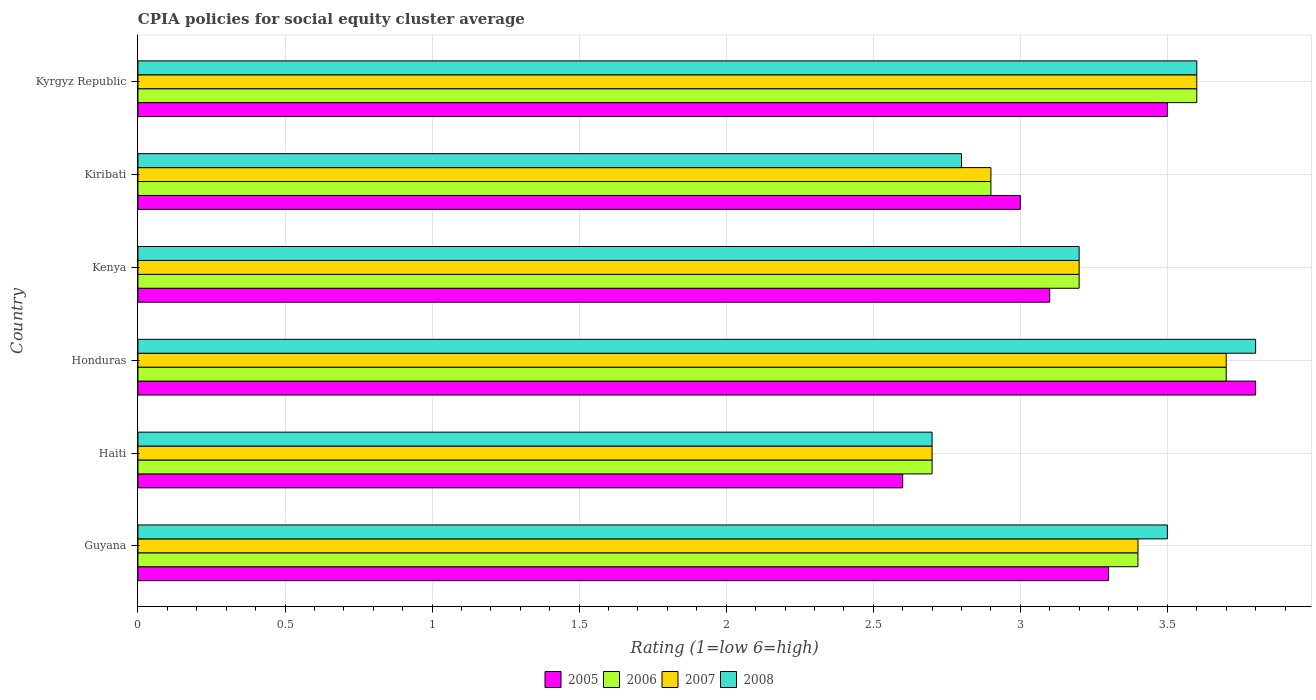What is the label of the 1st group of bars from the top?
Offer a very short reply. Kyrgyz Republic. In which country was the CPIA rating in 2008 maximum?
Your response must be concise. Honduras. In which country was the CPIA rating in 2007 minimum?
Give a very brief answer. Haiti. What is the total CPIA rating in 2005 in the graph?
Your response must be concise. 19.3. What is the difference between the CPIA rating in 2005 in Haiti and that in Kiribati?
Provide a succinct answer. -0.4. What is the difference between the CPIA rating in 2005 in Kyrgyz Republic and the CPIA rating in 2007 in Kenya?
Keep it short and to the point. 0.3. What is the average CPIA rating in 2008 per country?
Provide a short and direct response. 3.27. What is the difference between the CPIA rating in 2006 and CPIA rating in 2007 in Guyana?
Ensure brevity in your answer.  0. In how many countries, is the CPIA rating in 2005 greater than 3.7 ?
Your answer should be very brief. 1. What is the ratio of the CPIA rating in 2005 in Kiribati to that in Kyrgyz Republic?
Offer a terse response. 0.86. Is the CPIA rating in 2005 in Haiti less than that in Kyrgyz Republic?
Offer a very short reply. Yes. What is the difference between the highest and the second highest CPIA rating in 2008?
Offer a very short reply. 0.2. How many bars are there?
Provide a short and direct response. 24. Are all the bars in the graph horizontal?
Offer a terse response. Yes. What is the difference between two consecutive major ticks on the X-axis?
Give a very brief answer. 0.5. Are the values on the major ticks of X-axis written in scientific E-notation?
Make the answer very short. No. Does the graph contain grids?
Keep it short and to the point. Yes. What is the title of the graph?
Keep it short and to the point. CPIA policies for social equity cluster average. Does "2011" appear as one of the legend labels in the graph?
Your answer should be compact. No. What is the label or title of the X-axis?
Keep it short and to the point. Rating (1=low 6=high). What is the Rating (1=low 6=high) in 2005 in Guyana?
Give a very brief answer. 3.3. What is the Rating (1=low 6=high) of 2006 in Guyana?
Make the answer very short. 3.4. What is the Rating (1=low 6=high) of 2005 in Haiti?
Your answer should be very brief. 2.6. What is the Rating (1=low 6=high) of 2007 in Honduras?
Your response must be concise. 3.7. What is the Rating (1=low 6=high) of 2007 in Kenya?
Provide a short and direct response. 3.2. What is the Rating (1=low 6=high) in 2008 in Kiribati?
Offer a terse response. 2.8. What is the Rating (1=low 6=high) of 2005 in Kyrgyz Republic?
Your response must be concise. 3.5. Across all countries, what is the minimum Rating (1=low 6=high) in 2005?
Ensure brevity in your answer.  2.6. Across all countries, what is the minimum Rating (1=low 6=high) in 2007?
Provide a short and direct response. 2.7. Across all countries, what is the minimum Rating (1=low 6=high) of 2008?
Ensure brevity in your answer.  2.7. What is the total Rating (1=low 6=high) of 2005 in the graph?
Your answer should be compact. 19.3. What is the total Rating (1=low 6=high) of 2006 in the graph?
Ensure brevity in your answer.  19.5. What is the total Rating (1=low 6=high) in 2008 in the graph?
Offer a very short reply. 19.6. What is the difference between the Rating (1=low 6=high) in 2005 in Guyana and that in Honduras?
Provide a succinct answer. -0.5. What is the difference between the Rating (1=low 6=high) of 2007 in Guyana and that in Honduras?
Keep it short and to the point. -0.3. What is the difference between the Rating (1=low 6=high) in 2005 in Guyana and that in Kenya?
Give a very brief answer. 0.2. What is the difference between the Rating (1=low 6=high) in 2008 in Guyana and that in Kenya?
Your answer should be compact. 0.3. What is the difference between the Rating (1=low 6=high) in 2005 in Haiti and that in Honduras?
Your response must be concise. -1.2. What is the difference between the Rating (1=low 6=high) in 2008 in Haiti and that in Honduras?
Offer a very short reply. -1.1. What is the difference between the Rating (1=low 6=high) in 2005 in Haiti and that in Kenya?
Keep it short and to the point. -0.5. What is the difference between the Rating (1=low 6=high) of 2007 in Haiti and that in Kenya?
Your answer should be very brief. -0.5. What is the difference between the Rating (1=low 6=high) in 2008 in Haiti and that in Kenya?
Offer a terse response. -0.5. What is the difference between the Rating (1=low 6=high) in 2006 in Haiti and that in Kiribati?
Your response must be concise. -0.2. What is the difference between the Rating (1=low 6=high) in 2007 in Haiti and that in Kiribati?
Give a very brief answer. -0.2. What is the difference between the Rating (1=low 6=high) of 2008 in Haiti and that in Kiribati?
Offer a very short reply. -0.1. What is the difference between the Rating (1=low 6=high) of 2005 in Haiti and that in Kyrgyz Republic?
Your answer should be very brief. -0.9. What is the difference between the Rating (1=low 6=high) in 2006 in Haiti and that in Kyrgyz Republic?
Offer a very short reply. -0.9. What is the difference between the Rating (1=low 6=high) of 2008 in Haiti and that in Kyrgyz Republic?
Provide a succinct answer. -0.9. What is the difference between the Rating (1=low 6=high) of 2005 in Honduras and that in Kenya?
Your answer should be compact. 0.7. What is the difference between the Rating (1=low 6=high) in 2005 in Honduras and that in Kiribati?
Provide a succinct answer. 0.8. What is the difference between the Rating (1=low 6=high) in 2006 in Honduras and that in Kiribati?
Give a very brief answer. 0.8. What is the difference between the Rating (1=low 6=high) in 2007 in Honduras and that in Kiribati?
Make the answer very short. 0.8. What is the difference between the Rating (1=low 6=high) of 2008 in Honduras and that in Kiribati?
Your response must be concise. 1. What is the difference between the Rating (1=low 6=high) of 2005 in Honduras and that in Kyrgyz Republic?
Your answer should be very brief. 0.3. What is the difference between the Rating (1=low 6=high) in 2006 in Honduras and that in Kyrgyz Republic?
Your response must be concise. 0.1. What is the difference between the Rating (1=low 6=high) of 2007 in Honduras and that in Kyrgyz Republic?
Offer a very short reply. 0.1. What is the difference between the Rating (1=low 6=high) in 2007 in Kenya and that in Kiribati?
Offer a very short reply. 0.3. What is the difference between the Rating (1=low 6=high) of 2008 in Kenya and that in Kiribati?
Provide a short and direct response. 0.4. What is the difference between the Rating (1=low 6=high) of 2005 in Kenya and that in Kyrgyz Republic?
Provide a short and direct response. -0.4. What is the difference between the Rating (1=low 6=high) in 2006 in Kenya and that in Kyrgyz Republic?
Your answer should be compact. -0.4. What is the difference between the Rating (1=low 6=high) of 2008 in Kiribati and that in Kyrgyz Republic?
Your answer should be compact. -0.8. What is the difference between the Rating (1=low 6=high) of 2005 in Guyana and the Rating (1=low 6=high) of 2006 in Haiti?
Provide a succinct answer. 0.6. What is the difference between the Rating (1=low 6=high) of 2005 in Guyana and the Rating (1=low 6=high) of 2007 in Haiti?
Your answer should be very brief. 0.6. What is the difference between the Rating (1=low 6=high) of 2006 in Guyana and the Rating (1=low 6=high) of 2007 in Haiti?
Provide a short and direct response. 0.7. What is the difference between the Rating (1=low 6=high) of 2005 in Guyana and the Rating (1=low 6=high) of 2007 in Honduras?
Provide a short and direct response. -0.4. What is the difference between the Rating (1=low 6=high) in 2005 in Guyana and the Rating (1=low 6=high) in 2008 in Honduras?
Make the answer very short. -0.5. What is the difference between the Rating (1=low 6=high) in 2006 in Guyana and the Rating (1=low 6=high) in 2007 in Honduras?
Provide a short and direct response. -0.3. What is the difference between the Rating (1=low 6=high) in 2007 in Guyana and the Rating (1=low 6=high) in 2008 in Honduras?
Ensure brevity in your answer.  -0.4. What is the difference between the Rating (1=low 6=high) in 2005 in Guyana and the Rating (1=low 6=high) in 2006 in Kenya?
Provide a short and direct response. 0.1. What is the difference between the Rating (1=low 6=high) in 2005 in Guyana and the Rating (1=low 6=high) in 2008 in Kenya?
Offer a very short reply. 0.1. What is the difference between the Rating (1=low 6=high) in 2006 in Guyana and the Rating (1=low 6=high) in 2008 in Kenya?
Offer a very short reply. 0.2. What is the difference between the Rating (1=low 6=high) of 2005 in Guyana and the Rating (1=low 6=high) of 2006 in Kiribati?
Offer a very short reply. 0.4. What is the difference between the Rating (1=low 6=high) of 2005 in Guyana and the Rating (1=low 6=high) of 2007 in Kiribati?
Make the answer very short. 0.4. What is the difference between the Rating (1=low 6=high) in 2005 in Guyana and the Rating (1=low 6=high) in 2008 in Kiribati?
Make the answer very short. 0.5. What is the difference between the Rating (1=low 6=high) in 2006 in Guyana and the Rating (1=low 6=high) in 2008 in Kiribati?
Your response must be concise. 0.6. What is the difference between the Rating (1=low 6=high) in 2007 in Guyana and the Rating (1=low 6=high) in 2008 in Kiribati?
Your answer should be compact. 0.6. What is the difference between the Rating (1=low 6=high) of 2005 in Guyana and the Rating (1=low 6=high) of 2007 in Kyrgyz Republic?
Your response must be concise. -0.3. What is the difference between the Rating (1=low 6=high) in 2007 in Guyana and the Rating (1=low 6=high) in 2008 in Kyrgyz Republic?
Offer a terse response. -0.2. What is the difference between the Rating (1=low 6=high) of 2005 in Haiti and the Rating (1=low 6=high) of 2006 in Honduras?
Provide a succinct answer. -1.1. What is the difference between the Rating (1=low 6=high) of 2005 in Haiti and the Rating (1=low 6=high) of 2007 in Honduras?
Offer a very short reply. -1.1. What is the difference between the Rating (1=low 6=high) of 2006 in Haiti and the Rating (1=low 6=high) of 2007 in Honduras?
Your response must be concise. -1. What is the difference between the Rating (1=low 6=high) of 2007 in Haiti and the Rating (1=low 6=high) of 2008 in Honduras?
Your answer should be very brief. -1.1. What is the difference between the Rating (1=low 6=high) of 2005 in Haiti and the Rating (1=low 6=high) of 2006 in Kenya?
Keep it short and to the point. -0.6. What is the difference between the Rating (1=low 6=high) of 2006 in Haiti and the Rating (1=low 6=high) of 2007 in Kenya?
Make the answer very short. -0.5. What is the difference between the Rating (1=low 6=high) in 2006 in Haiti and the Rating (1=low 6=high) in 2008 in Kenya?
Offer a terse response. -0.5. What is the difference between the Rating (1=low 6=high) of 2007 in Haiti and the Rating (1=low 6=high) of 2008 in Kenya?
Provide a succinct answer. -0.5. What is the difference between the Rating (1=low 6=high) of 2005 in Haiti and the Rating (1=low 6=high) of 2006 in Kiribati?
Your response must be concise. -0.3. What is the difference between the Rating (1=low 6=high) of 2005 in Haiti and the Rating (1=low 6=high) of 2007 in Kiribati?
Provide a short and direct response. -0.3. What is the difference between the Rating (1=low 6=high) in 2005 in Haiti and the Rating (1=low 6=high) in 2008 in Kiribati?
Provide a succinct answer. -0.2. What is the difference between the Rating (1=low 6=high) in 2006 in Haiti and the Rating (1=low 6=high) in 2007 in Kiribati?
Provide a succinct answer. -0.2. What is the difference between the Rating (1=low 6=high) of 2007 in Haiti and the Rating (1=low 6=high) of 2008 in Kiribati?
Make the answer very short. -0.1. What is the difference between the Rating (1=low 6=high) of 2005 in Haiti and the Rating (1=low 6=high) of 2007 in Kyrgyz Republic?
Your answer should be compact. -1. What is the difference between the Rating (1=low 6=high) in 2005 in Haiti and the Rating (1=low 6=high) in 2008 in Kyrgyz Republic?
Keep it short and to the point. -1. What is the difference between the Rating (1=low 6=high) in 2006 in Haiti and the Rating (1=low 6=high) in 2008 in Kyrgyz Republic?
Your answer should be very brief. -0.9. What is the difference between the Rating (1=low 6=high) of 2005 in Honduras and the Rating (1=low 6=high) of 2007 in Kenya?
Offer a terse response. 0.6. What is the difference between the Rating (1=low 6=high) in 2005 in Honduras and the Rating (1=low 6=high) in 2008 in Kenya?
Your answer should be very brief. 0.6. What is the difference between the Rating (1=low 6=high) in 2005 in Honduras and the Rating (1=low 6=high) in 2006 in Kiribati?
Ensure brevity in your answer.  0.9. What is the difference between the Rating (1=low 6=high) in 2005 in Honduras and the Rating (1=low 6=high) in 2006 in Kyrgyz Republic?
Provide a succinct answer. 0.2. What is the difference between the Rating (1=low 6=high) of 2005 in Honduras and the Rating (1=low 6=high) of 2007 in Kyrgyz Republic?
Ensure brevity in your answer.  0.2. What is the difference between the Rating (1=low 6=high) of 2005 in Kenya and the Rating (1=low 6=high) of 2006 in Kiribati?
Provide a short and direct response. 0.2. What is the difference between the Rating (1=low 6=high) in 2005 in Kenya and the Rating (1=low 6=high) in 2007 in Kiribati?
Make the answer very short. 0.2. What is the difference between the Rating (1=low 6=high) of 2005 in Kenya and the Rating (1=low 6=high) of 2008 in Kiribati?
Your response must be concise. 0.3. What is the difference between the Rating (1=low 6=high) in 2006 in Kenya and the Rating (1=low 6=high) in 2008 in Kiribati?
Offer a terse response. 0.4. What is the difference between the Rating (1=low 6=high) in 2007 in Kenya and the Rating (1=low 6=high) in 2008 in Kiribati?
Make the answer very short. 0.4. What is the difference between the Rating (1=low 6=high) of 2005 in Kenya and the Rating (1=low 6=high) of 2008 in Kyrgyz Republic?
Your response must be concise. -0.5. What is the difference between the Rating (1=low 6=high) of 2006 in Kenya and the Rating (1=low 6=high) of 2007 in Kyrgyz Republic?
Give a very brief answer. -0.4. What is the difference between the Rating (1=low 6=high) of 2006 in Kenya and the Rating (1=low 6=high) of 2008 in Kyrgyz Republic?
Your response must be concise. -0.4. What is the difference between the Rating (1=low 6=high) of 2005 in Kiribati and the Rating (1=low 6=high) of 2008 in Kyrgyz Republic?
Your answer should be very brief. -0.6. What is the average Rating (1=low 6=high) of 2005 per country?
Provide a short and direct response. 3.22. What is the average Rating (1=low 6=high) in 2006 per country?
Ensure brevity in your answer.  3.25. What is the average Rating (1=low 6=high) of 2007 per country?
Offer a very short reply. 3.25. What is the average Rating (1=low 6=high) of 2008 per country?
Offer a terse response. 3.27. What is the difference between the Rating (1=low 6=high) in 2005 and Rating (1=low 6=high) in 2006 in Guyana?
Give a very brief answer. -0.1. What is the difference between the Rating (1=low 6=high) in 2005 and Rating (1=low 6=high) in 2007 in Guyana?
Keep it short and to the point. -0.1. What is the difference between the Rating (1=low 6=high) of 2006 and Rating (1=low 6=high) of 2007 in Guyana?
Make the answer very short. 0. What is the difference between the Rating (1=low 6=high) of 2005 and Rating (1=low 6=high) of 2008 in Haiti?
Your answer should be very brief. -0.1. What is the difference between the Rating (1=low 6=high) in 2006 and Rating (1=low 6=high) in 2007 in Haiti?
Give a very brief answer. 0. What is the difference between the Rating (1=low 6=high) in 2006 and Rating (1=low 6=high) in 2008 in Haiti?
Offer a very short reply. 0. What is the difference between the Rating (1=low 6=high) of 2007 and Rating (1=low 6=high) of 2008 in Haiti?
Ensure brevity in your answer.  0. What is the difference between the Rating (1=low 6=high) in 2005 and Rating (1=low 6=high) in 2006 in Honduras?
Offer a very short reply. 0.1. What is the difference between the Rating (1=low 6=high) of 2005 and Rating (1=low 6=high) of 2007 in Honduras?
Offer a very short reply. 0.1. What is the difference between the Rating (1=low 6=high) of 2005 and Rating (1=low 6=high) of 2008 in Honduras?
Provide a short and direct response. 0. What is the difference between the Rating (1=low 6=high) in 2006 and Rating (1=low 6=high) in 2007 in Honduras?
Provide a succinct answer. 0. What is the difference between the Rating (1=low 6=high) in 2006 and Rating (1=low 6=high) in 2008 in Honduras?
Your response must be concise. -0.1. What is the difference between the Rating (1=low 6=high) of 2005 and Rating (1=low 6=high) of 2006 in Kenya?
Keep it short and to the point. -0.1. What is the difference between the Rating (1=low 6=high) in 2005 and Rating (1=low 6=high) in 2007 in Kenya?
Provide a succinct answer. -0.1. What is the difference between the Rating (1=low 6=high) in 2005 and Rating (1=low 6=high) in 2008 in Kenya?
Offer a very short reply. -0.1. What is the difference between the Rating (1=low 6=high) in 2006 and Rating (1=low 6=high) in 2008 in Kenya?
Give a very brief answer. 0. What is the difference between the Rating (1=low 6=high) in 2005 and Rating (1=low 6=high) in 2008 in Kiribati?
Ensure brevity in your answer.  0.2. What is the difference between the Rating (1=low 6=high) in 2006 and Rating (1=low 6=high) in 2007 in Kiribati?
Provide a succinct answer. 0. What is the difference between the Rating (1=low 6=high) of 2007 and Rating (1=low 6=high) of 2008 in Kiribati?
Provide a short and direct response. 0.1. What is the difference between the Rating (1=low 6=high) in 2005 and Rating (1=low 6=high) in 2007 in Kyrgyz Republic?
Your answer should be compact. -0.1. What is the difference between the Rating (1=low 6=high) of 2006 and Rating (1=low 6=high) of 2008 in Kyrgyz Republic?
Offer a terse response. 0. What is the ratio of the Rating (1=low 6=high) of 2005 in Guyana to that in Haiti?
Keep it short and to the point. 1.27. What is the ratio of the Rating (1=low 6=high) in 2006 in Guyana to that in Haiti?
Provide a succinct answer. 1.26. What is the ratio of the Rating (1=low 6=high) in 2007 in Guyana to that in Haiti?
Keep it short and to the point. 1.26. What is the ratio of the Rating (1=low 6=high) in 2008 in Guyana to that in Haiti?
Offer a very short reply. 1.3. What is the ratio of the Rating (1=low 6=high) in 2005 in Guyana to that in Honduras?
Your response must be concise. 0.87. What is the ratio of the Rating (1=low 6=high) of 2006 in Guyana to that in Honduras?
Offer a very short reply. 0.92. What is the ratio of the Rating (1=low 6=high) in 2007 in Guyana to that in Honduras?
Provide a succinct answer. 0.92. What is the ratio of the Rating (1=low 6=high) in 2008 in Guyana to that in Honduras?
Give a very brief answer. 0.92. What is the ratio of the Rating (1=low 6=high) in 2005 in Guyana to that in Kenya?
Give a very brief answer. 1.06. What is the ratio of the Rating (1=low 6=high) in 2006 in Guyana to that in Kenya?
Offer a very short reply. 1.06. What is the ratio of the Rating (1=low 6=high) of 2008 in Guyana to that in Kenya?
Your answer should be compact. 1.09. What is the ratio of the Rating (1=low 6=high) in 2006 in Guyana to that in Kiribati?
Provide a succinct answer. 1.17. What is the ratio of the Rating (1=low 6=high) in 2007 in Guyana to that in Kiribati?
Give a very brief answer. 1.17. What is the ratio of the Rating (1=low 6=high) of 2008 in Guyana to that in Kiribati?
Your response must be concise. 1.25. What is the ratio of the Rating (1=low 6=high) of 2005 in Guyana to that in Kyrgyz Republic?
Provide a short and direct response. 0.94. What is the ratio of the Rating (1=low 6=high) of 2006 in Guyana to that in Kyrgyz Republic?
Make the answer very short. 0.94. What is the ratio of the Rating (1=low 6=high) of 2007 in Guyana to that in Kyrgyz Republic?
Your answer should be compact. 0.94. What is the ratio of the Rating (1=low 6=high) of 2008 in Guyana to that in Kyrgyz Republic?
Provide a succinct answer. 0.97. What is the ratio of the Rating (1=low 6=high) in 2005 in Haiti to that in Honduras?
Keep it short and to the point. 0.68. What is the ratio of the Rating (1=low 6=high) in 2006 in Haiti to that in Honduras?
Keep it short and to the point. 0.73. What is the ratio of the Rating (1=low 6=high) in 2007 in Haiti to that in Honduras?
Keep it short and to the point. 0.73. What is the ratio of the Rating (1=low 6=high) of 2008 in Haiti to that in Honduras?
Provide a succinct answer. 0.71. What is the ratio of the Rating (1=low 6=high) of 2005 in Haiti to that in Kenya?
Offer a terse response. 0.84. What is the ratio of the Rating (1=low 6=high) of 2006 in Haiti to that in Kenya?
Ensure brevity in your answer.  0.84. What is the ratio of the Rating (1=low 6=high) of 2007 in Haiti to that in Kenya?
Ensure brevity in your answer.  0.84. What is the ratio of the Rating (1=low 6=high) of 2008 in Haiti to that in Kenya?
Give a very brief answer. 0.84. What is the ratio of the Rating (1=low 6=high) in 2005 in Haiti to that in Kiribati?
Ensure brevity in your answer.  0.87. What is the ratio of the Rating (1=low 6=high) in 2006 in Haiti to that in Kiribati?
Ensure brevity in your answer.  0.93. What is the ratio of the Rating (1=low 6=high) of 2005 in Haiti to that in Kyrgyz Republic?
Offer a terse response. 0.74. What is the ratio of the Rating (1=low 6=high) in 2006 in Haiti to that in Kyrgyz Republic?
Your answer should be very brief. 0.75. What is the ratio of the Rating (1=low 6=high) of 2005 in Honduras to that in Kenya?
Make the answer very short. 1.23. What is the ratio of the Rating (1=low 6=high) of 2006 in Honduras to that in Kenya?
Your answer should be compact. 1.16. What is the ratio of the Rating (1=low 6=high) of 2007 in Honduras to that in Kenya?
Your response must be concise. 1.16. What is the ratio of the Rating (1=low 6=high) of 2008 in Honduras to that in Kenya?
Provide a succinct answer. 1.19. What is the ratio of the Rating (1=low 6=high) of 2005 in Honduras to that in Kiribati?
Offer a terse response. 1.27. What is the ratio of the Rating (1=low 6=high) in 2006 in Honduras to that in Kiribati?
Provide a succinct answer. 1.28. What is the ratio of the Rating (1=low 6=high) in 2007 in Honduras to that in Kiribati?
Your answer should be compact. 1.28. What is the ratio of the Rating (1=low 6=high) of 2008 in Honduras to that in Kiribati?
Provide a succinct answer. 1.36. What is the ratio of the Rating (1=low 6=high) of 2005 in Honduras to that in Kyrgyz Republic?
Provide a short and direct response. 1.09. What is the ratio of the Rating (1=low 6=high) of 2006 in Honduras to that in Kyrgyz Republic?
Offer a terse response. 1.03. What is the ratio of the Rating (1=low 6=high) in 2007 in Honduras to that in Kyrgyz Republic?
Provide a succinct answer. 1.03. What is the ratio of the Rating (1=low 6=high) in 2008 in Honduras to that in Kyrgyz Republic?
Your answer should be compact. 1.06. What is the ratio of the Rating (1=low 6=high) of 2005 in Kenya to that in Kiribati?
Provide a succinct answer. 1.03. What is the ratio of the Rating (1=low 6=high) of 2006 in Kenya to that in Kiribati?
Your answer should be very brief. 1.1. What is the ratio of the Rating (1=low 6=high) of 2007 in Kenya to that in Kiribati?
Provide a short and direct response. 1.1. What is the ratio of the Rating (1=low 6=high) in 2005 in Kenya to that in Kyrgyz Republic?
Offer a terse response. 0.89. What is the ratio of the Rating (1=low 6=high) of 2006 in Kenya to that in Kyrgyz Republic?
Make the answer very short. 0.89. What is the ratio of the Rating (1=low 6=high) in 2007 in Kenya to that in Kyrgyz Republic?
Ensure brevity in your answer.  0.89. What is the ratio of the Rating (1=low 6=high) of 2005 in Kiribati to that in Kyrgyz Republic?
Provide a succinct answer. 0.86. What is the ratio of the Rating (1=low 6=high) of 2006 in Kiribati to that in Kyrgyz Republic?
Provide a succinct answer. 0.81. What is the ratio of the Rating (1=low 6=high) of 2007 in Kiribati to that in Kyrgyz Republic?
Ensure brevity in your answer.  0.81. What is the difference between the highest and the second highest Rating (1=low 6=high) of 2005?
Keep it short and to the point. 0.3. What is the difference between the highest and the second highest Rating (1=low 6=high) in 2008?
Provide a succinct answer. 0.2. What is the difference between the highest and the lowest Rating (1=low 6=high) of 2005?
Make the answer very short. 1.2. What is the difference between the highest and the lowest Rating (1=low 6=high) of 2007?
Your answer should be compact. 1. 